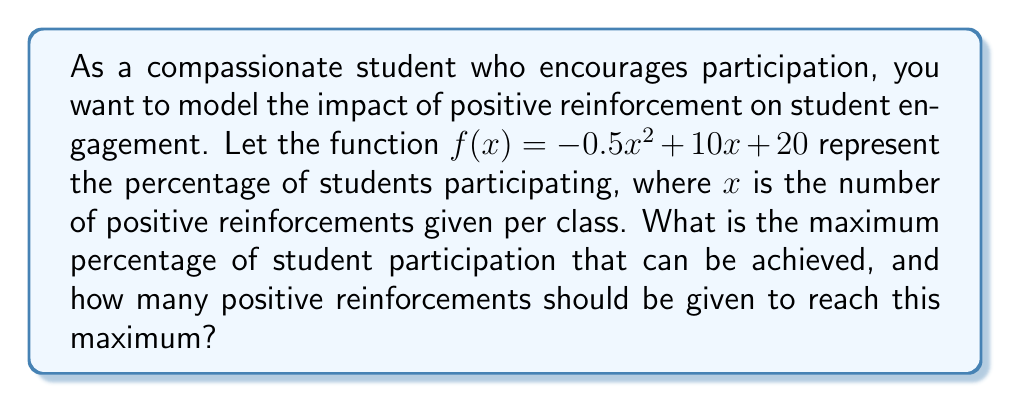Show me your answer to this math problem. 1. The given quadratic function is $f(x) = -0.5x^2 + 10x + 20$, where:
   - $f(x)$ represents the percentage of students participating
   - $x$ represents the number of positive reinforcements given per class

2. To find the maximum value of a quadratic function, we need to find the vertex of the parabola. For a quadratic function in the form $f(x) = ax^2 + bx + c$, the x-coordinate of the vertex is given by $x = -\frac{b}{2a}$.

3. In this case, $a = -0.5$, $b = 10$, and $c = 20$.

4. Calculate the x-coordinate of the vertex:
   $x = -\frac{b}{2a} = -\frac{10}{2(-0.5)} = -\frac{10}{-1} = 10$

5. To find the maximum percentage of student participation, substitute $x = 10$ into the original function:
   $f(10) = -0.5(10)^2 + 10(10) + 20$
   $= -0.5(100) + 100 + 20$
   $= -50 + 100 + 20$
   $= 70$

6. Therefore, the maximum percentage of student participation is 70%, and this is achieved when 10 positive reinforcements are given per class.
Answer: Maximum participation: 70%; Number of reinforcements: 10 